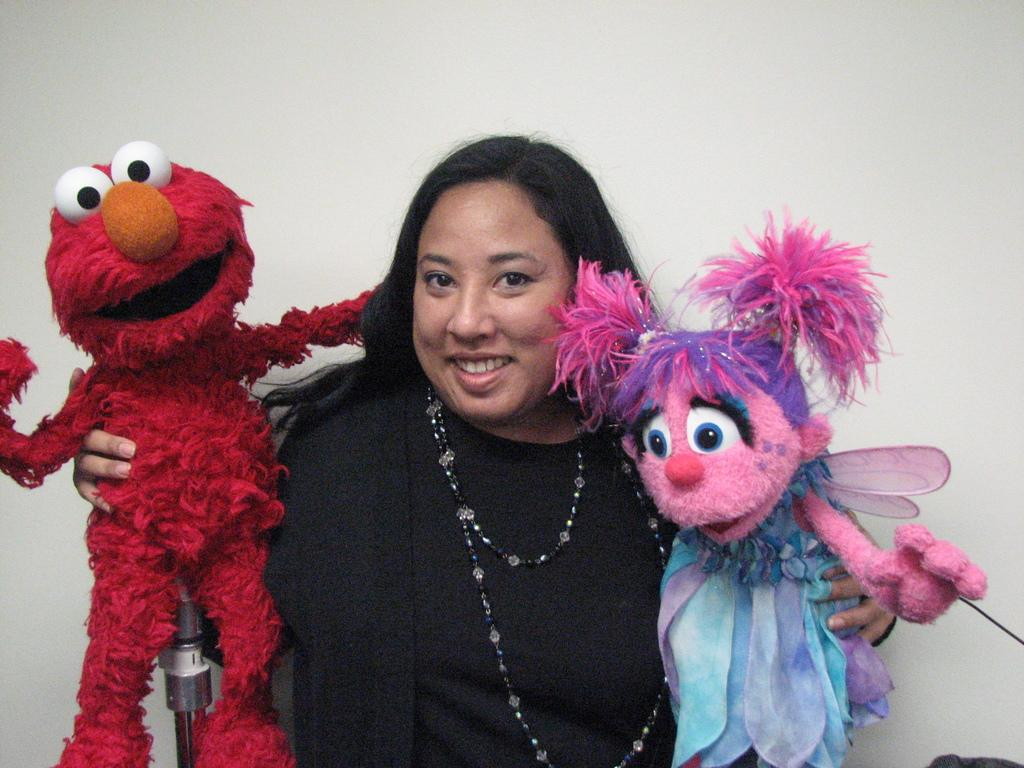What is the main subject of the image? There is a woman standing in the image. What can be seen on both sides of the woman? There are toys on both sides of the woman. What type of pet is the woman holding in the image? There is no pet visible in the image; the woman is standing with toys on both sides. 